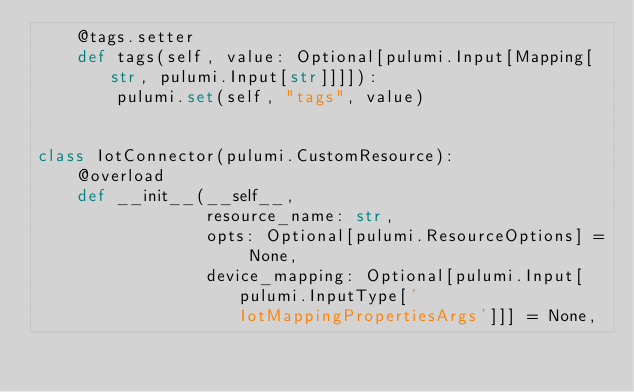<code> <loc_0><loc_0><loc_500><loc_500><_Python_>    @tags.setter
    def tags(self, value: Optional[pulumi.Input[Mapping[str, pulumi.Input[str]]]]):
        pulumi.set(self, "tags", value)


class IotConnector(pulumi.CustomResource):
    @overload
    def __init__(__self__,
                 resource_name: str,
                 opts: Optional[pulumi.ResourceOptions] = None,
                 device_mapping: Optional[pulumi.Input[pulumi.InputType['IotMappingPropertiesArgs']]] = None,</code> 